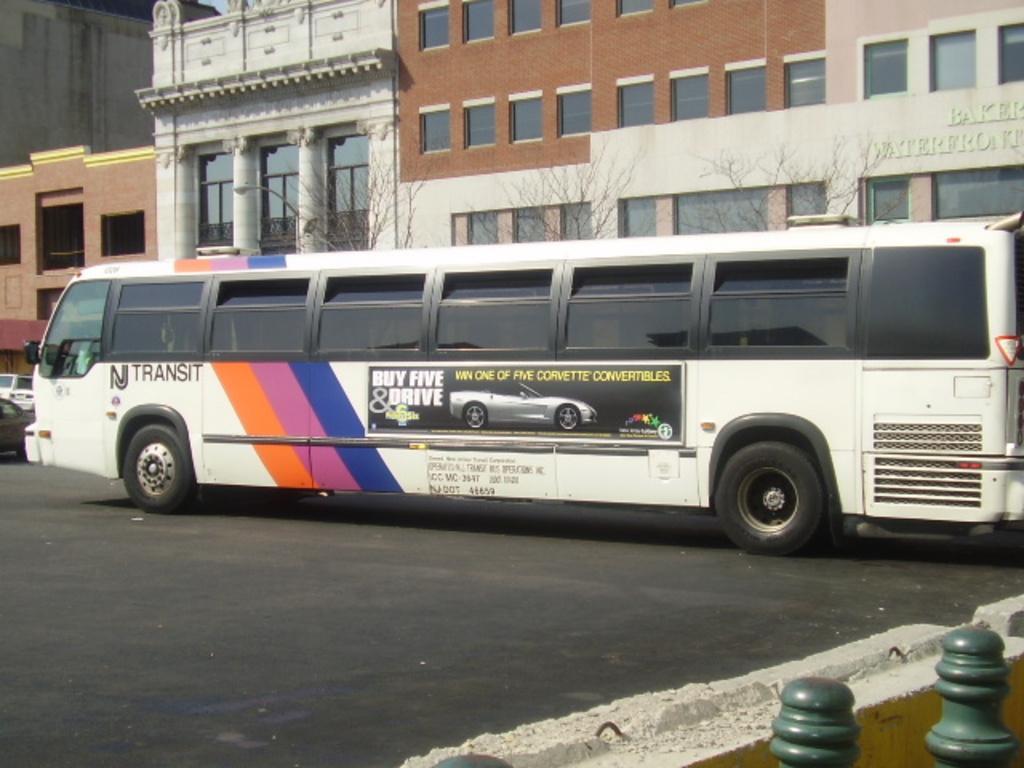In one or two sentences, can you explain what this image depicts? In this picture we can see poles and vehicles on the road. In the background of the image we can see buildings, light and trees. 